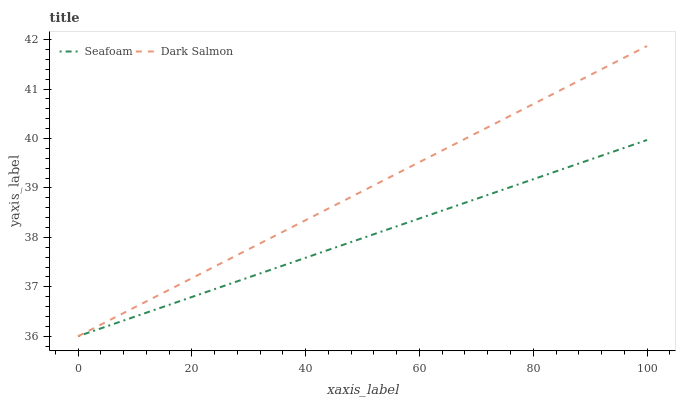Does Seafoam have the minimum area under the curve?
Answer yes or no. Yes. Does Dark Salmon have the maximum area under the curve?
Answer yes or no. Yes. Does Dark Salmon have the minimum area under the curve?
Answer yes or no. No. Is Seafoam the smoothest?
Answer yes or no. Yes. Is Dark Salmon the roughest?
Answer yes or no. Yes. Does Seafoam have the lowest value?
Answer yes or no. Yes. Does Dark Salmon have the highest value?
Answer yes or no. Yes. Does Dark Salmon intersect Seafoam?
Answer yes or no. Yes. Is Dark Salmon less than Seafoam?
Answer yes or no. No. Is Dark Salmon greater than Seafoam?
Answer yes or no. No. 